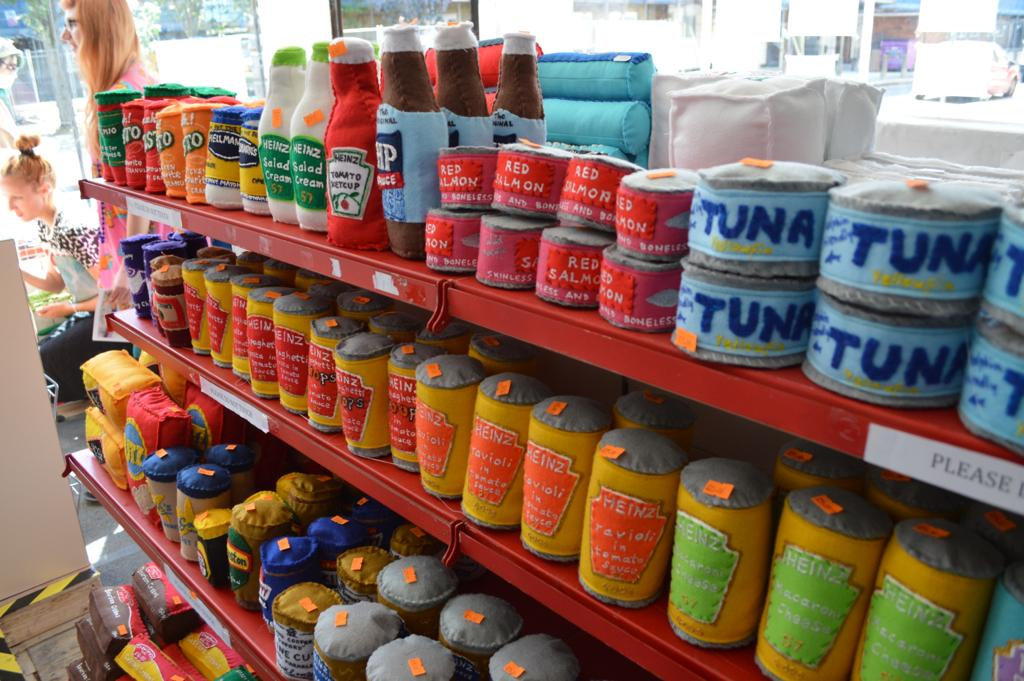<image>
Share a concise interpretation of the image provided. Several blue cans of tuna and red salmon on the top shelf. 